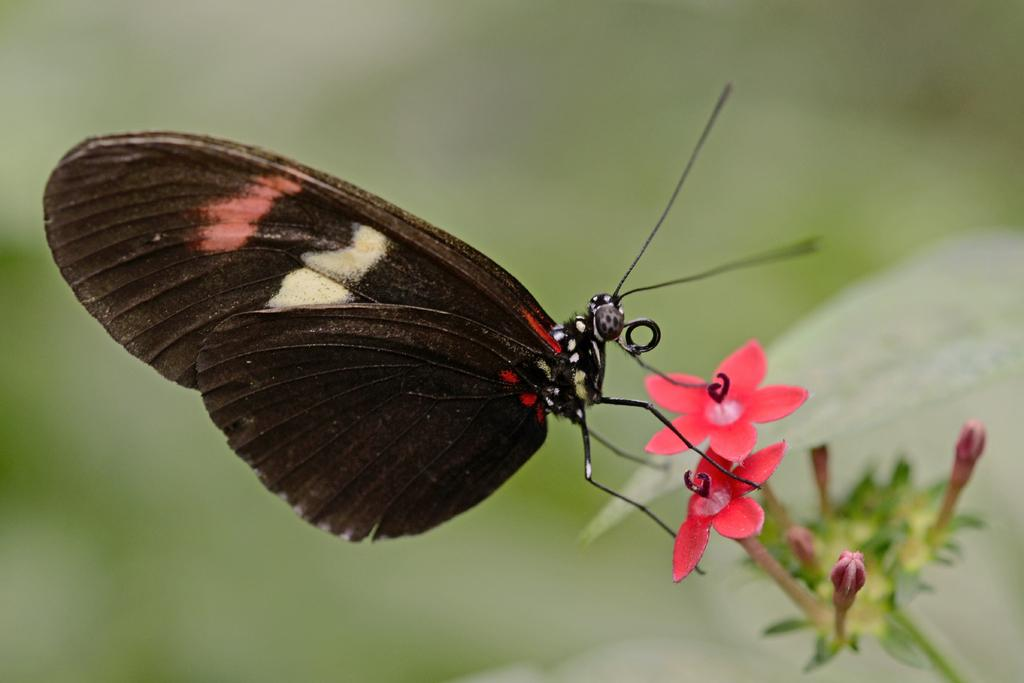What is the main subject of the image? There is a butterfly in the image. Where is the butterfly located in the image? The butterfly is on the flower of a plant. What type of education does the watch provide in the image? There is no watch present in the image, so it cannot provide any education. 